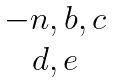<formula> <loc_0><loc_0><loc_500><loc_500>\begin{matrix} - n , b , c \\ d , e \end{matrix}</formula> 